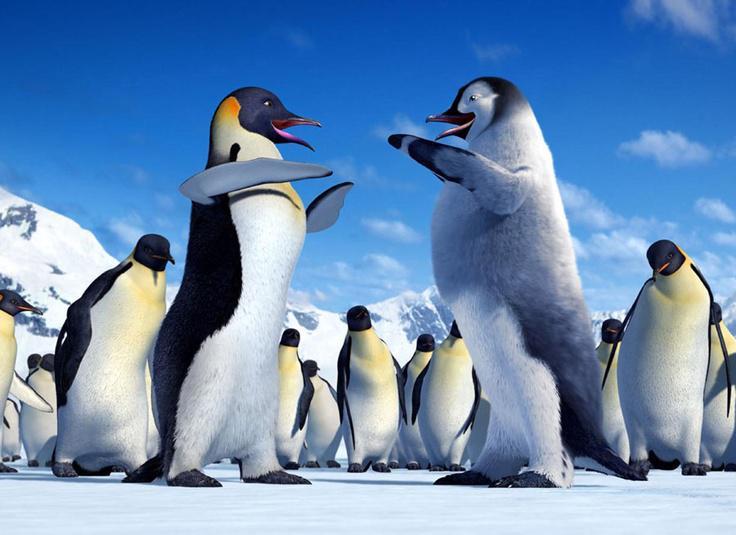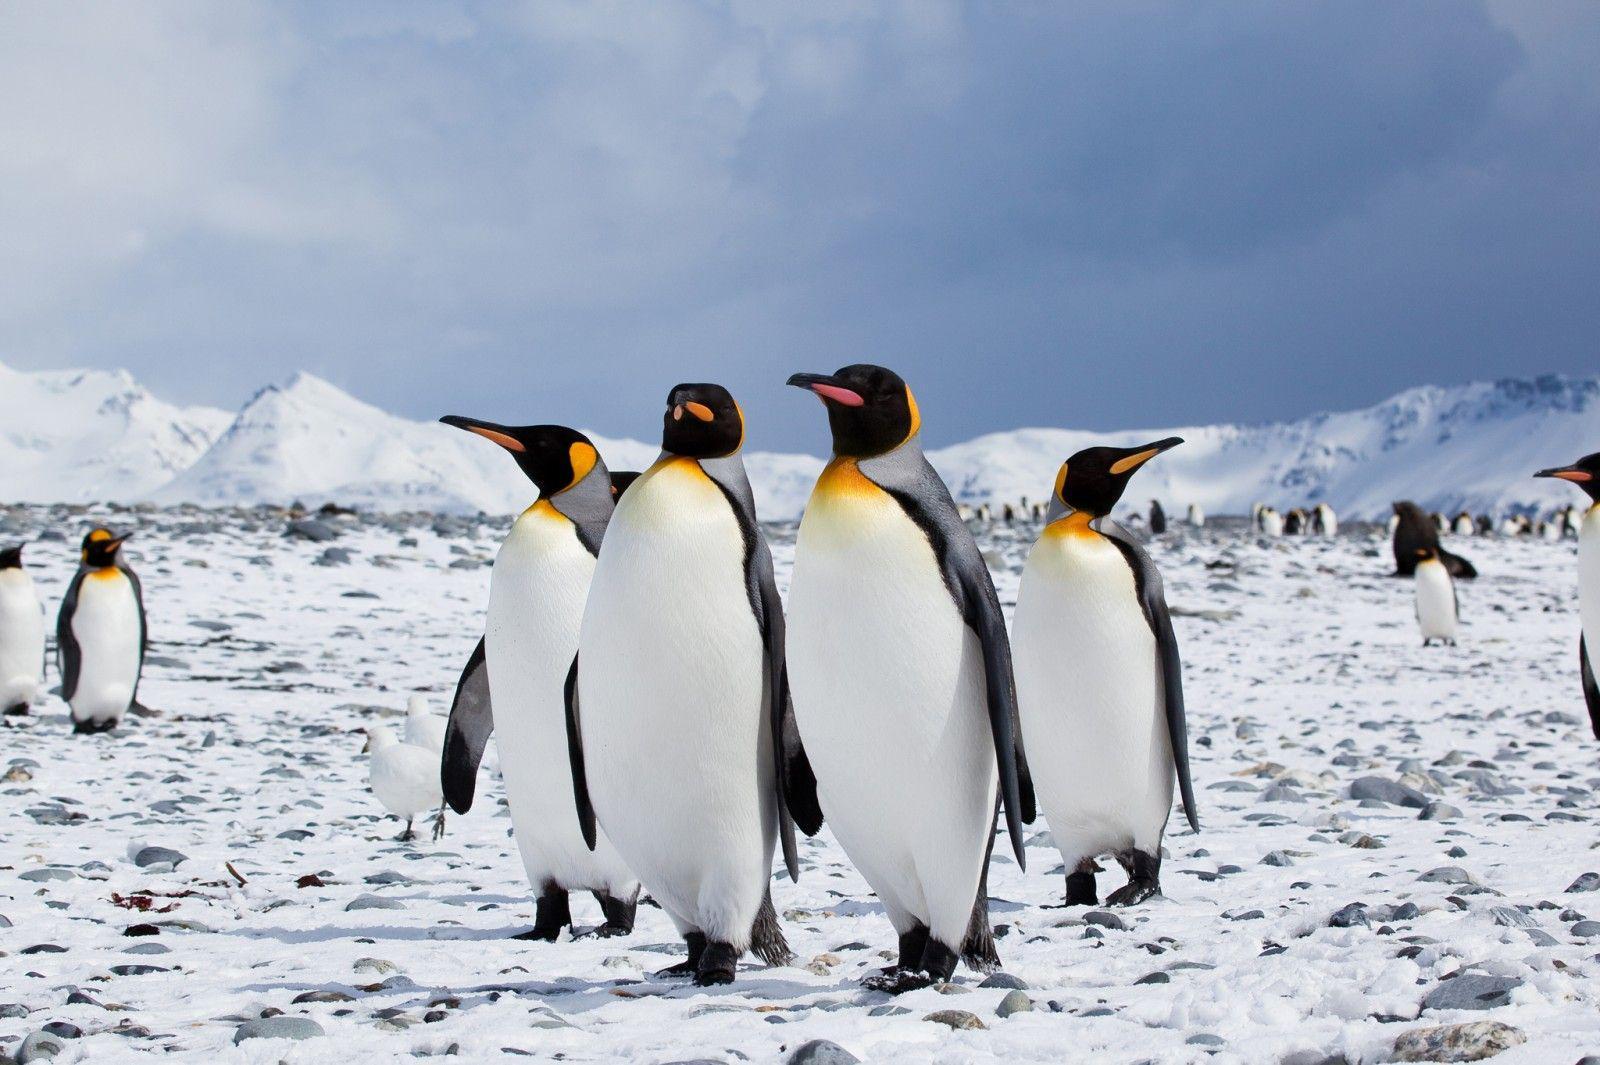The first image is the image on the left, the second image is the image on the right. Evaluate the accuracy of this statement regarding the images: "In at least one of the imagines there is a view of the beach with no more than 3 penguins walking together.". Is it true? Answer yes or no. No. The first image is the image on the left, the second image is the image on the right. For the images displayed, is the sentence "Penguins in the left image are walking on ice." factually correct? Answer yes or no. Yes. 